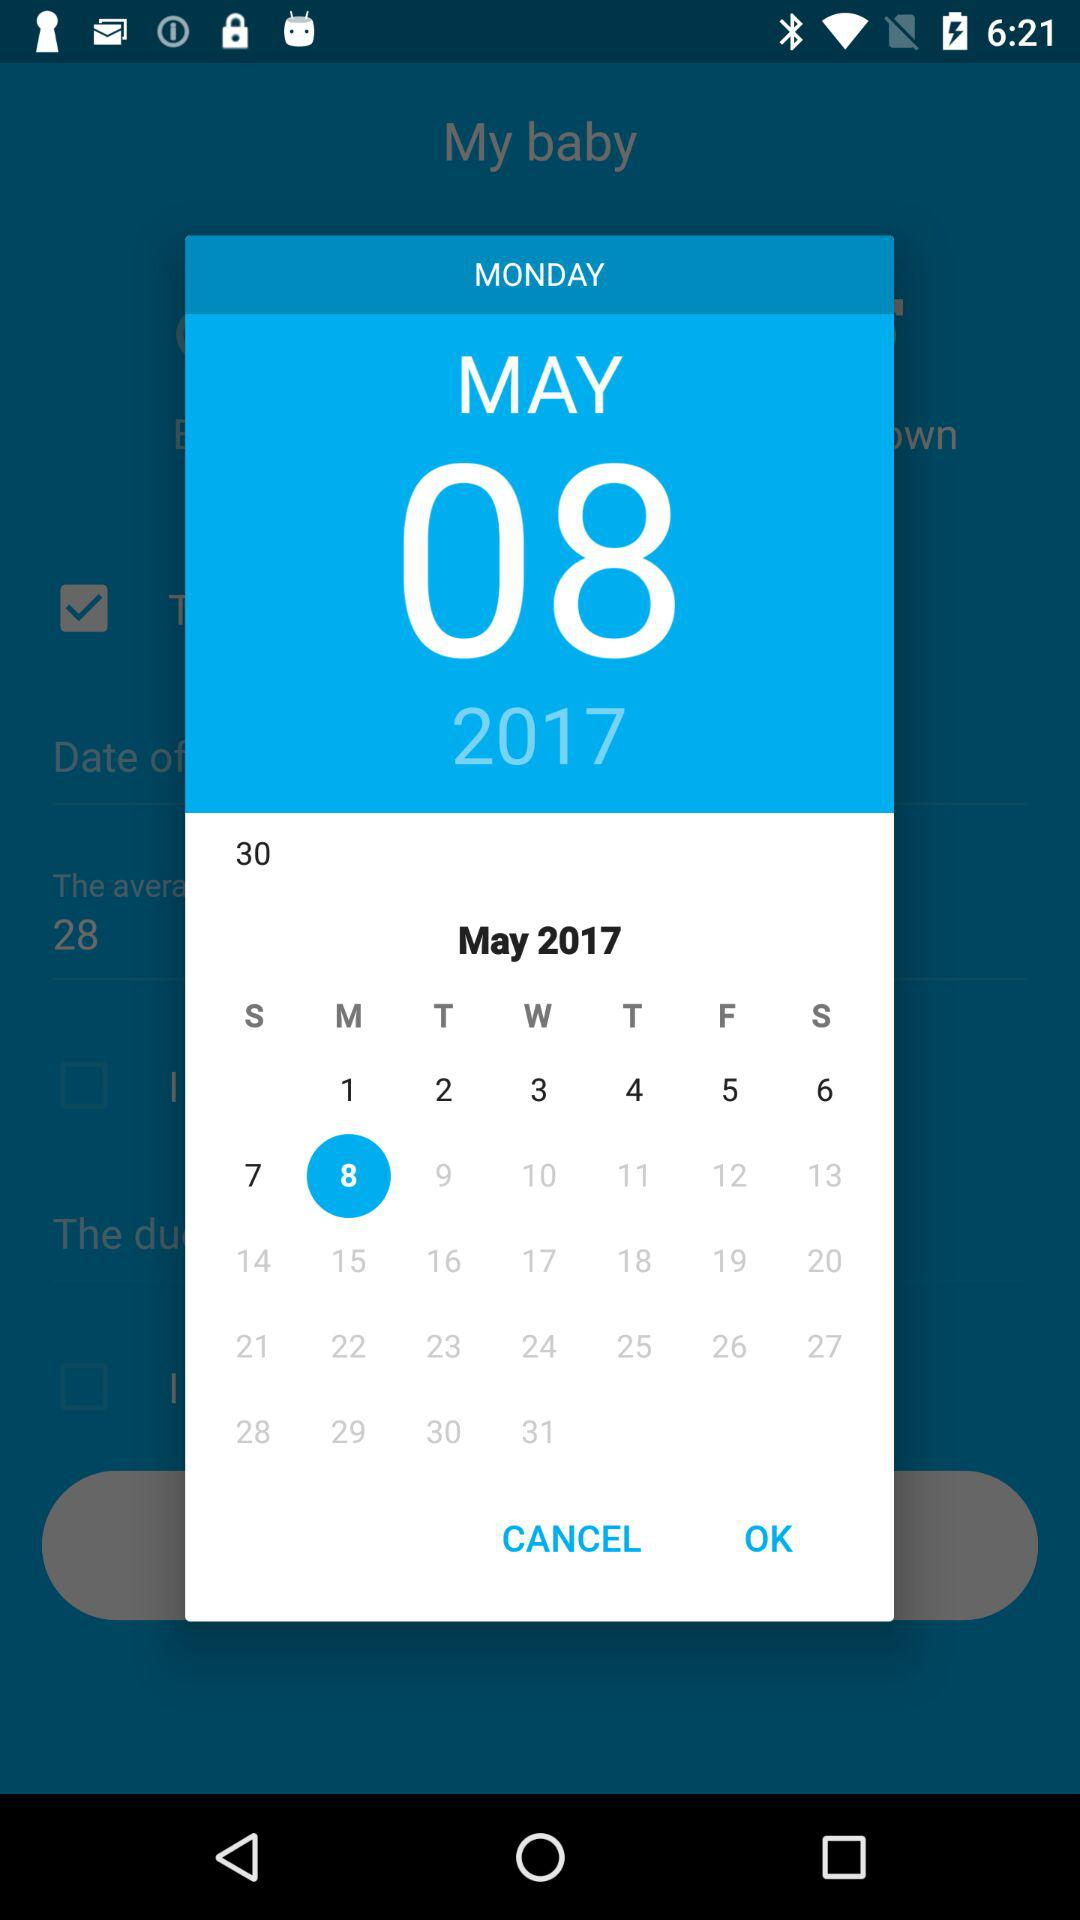What's the selected date? The selected date is Monday, May 8, 2017. 